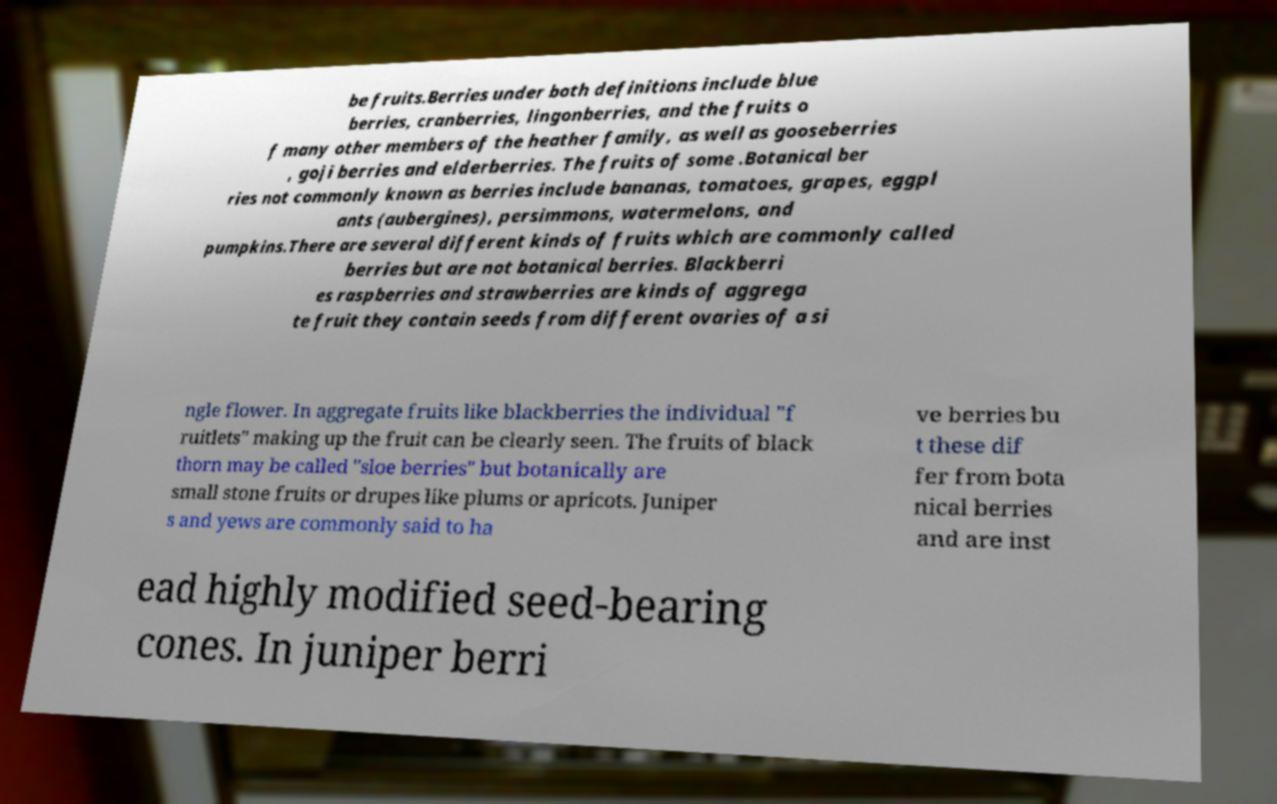Can you read and provide the text displayed in the image?This photo seems to have some interesting text. Can you extract and type it out for me? be fruits.Berries under both definitions include blue berries, cranberries, lingonberries, and the fruits o f many other members of the heather family, as well as gooseberries , goji berries and elderberries. The fruits of some .Botanical ber ries not commonly known as berries include bananas, tomatoes, grapes, eggpl ants (aubergines), persimmons, watermelons, and pumpkins.There are several different kinds of fruits which are commonly called berries but are not botanical berries. Blackberri es raspberries and strawberries are kinds of aggrega te fruit they contain seeds from different ovaries of a si ngle flower. In aggregate fruits like blackberries the individual "f ruitlets" making up the fruit can be clearly seen. The fruits of black thorn may be called "sloe berries" but botanically are small stone fruits or drupes like plums or apricots. Juniper s and yews are commonly said to ha ve berries bu t these dif fer from bota nical berries and are inst ead highly modified seed-bearing cones. In juniper berri 